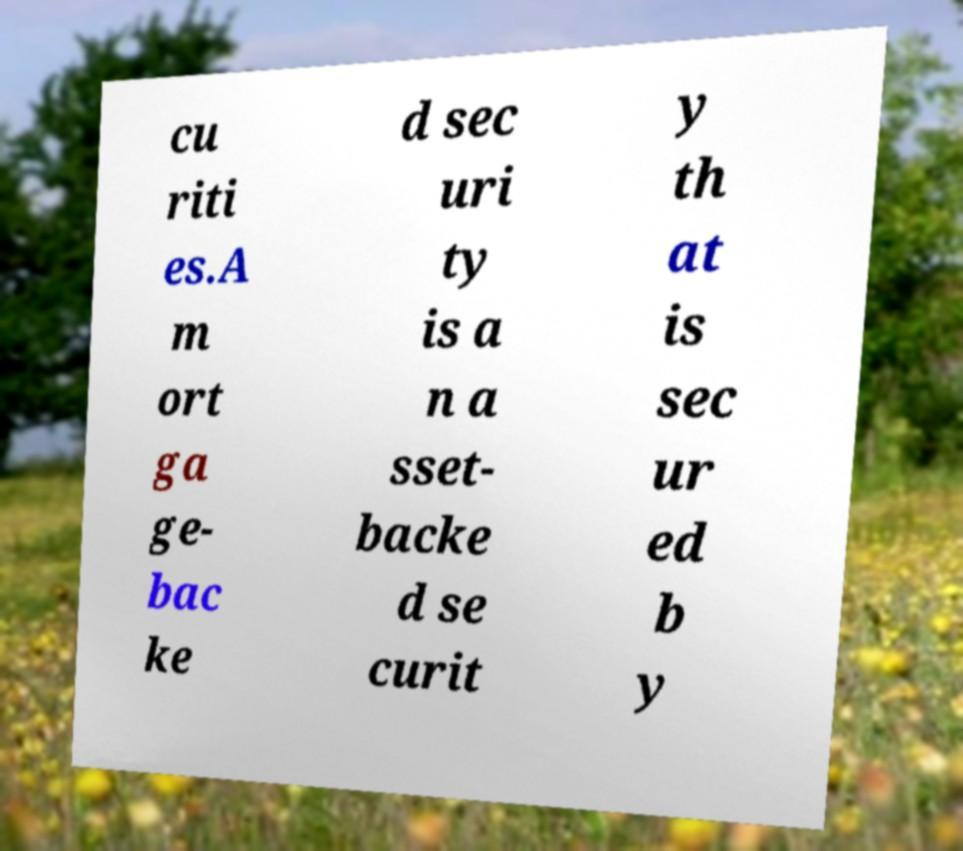Can you accurately transcribe the text from the provided image for me? cu riti es.A m ort ga ge- bac ke d sec uri ty is a n a sset- backe d se curit y th at is sec ur ed b y 